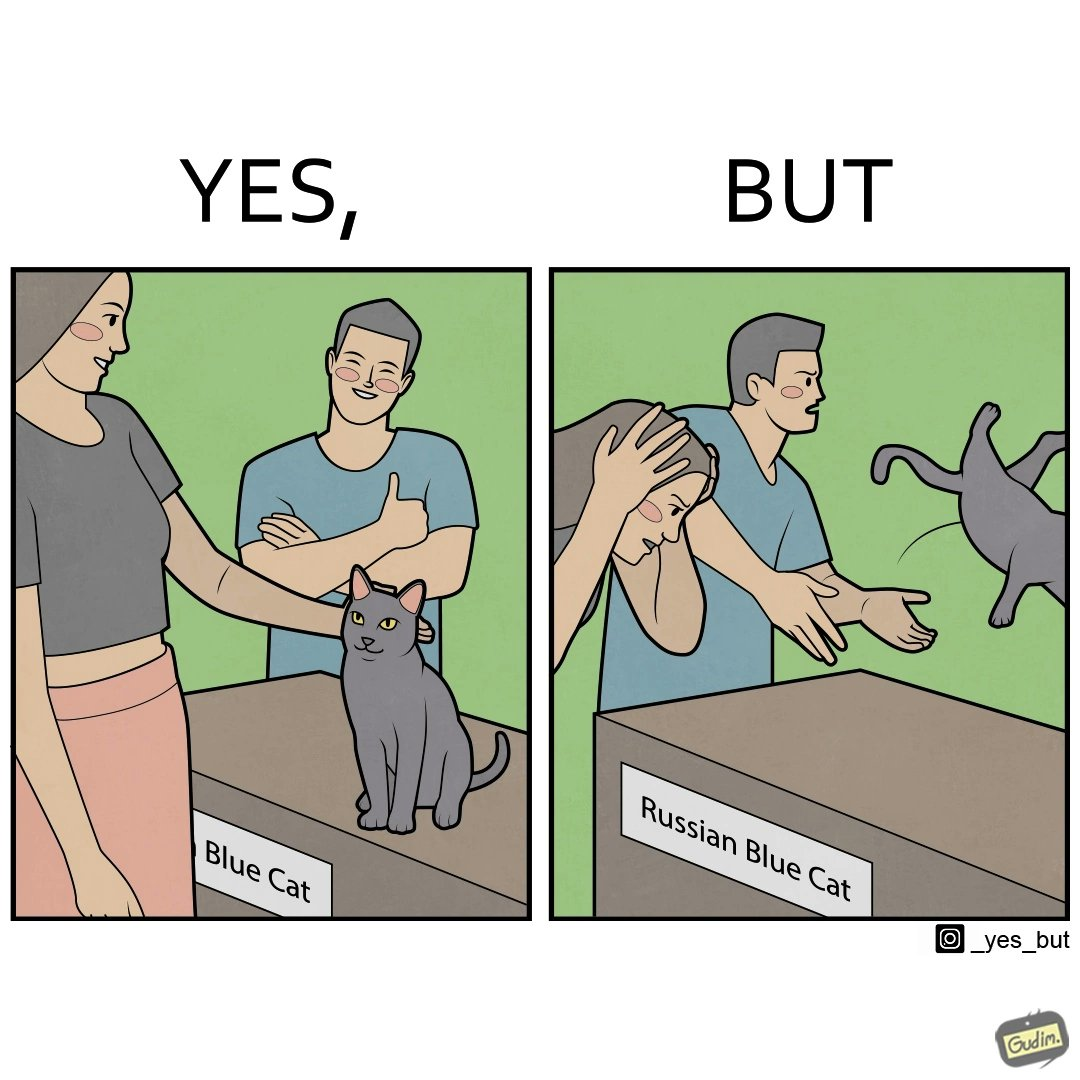What makes this image funny or satirical? The image is confusing, as initially, when the label reads "Blue Cat", the people are happy and are petting tha cat, but as soon as one of them realizes that the entire text reads "Russian Blue Cat", they seem to worried, and one of them throws away the cat. For some reason, the word "Russian" is a trigger word for them. 